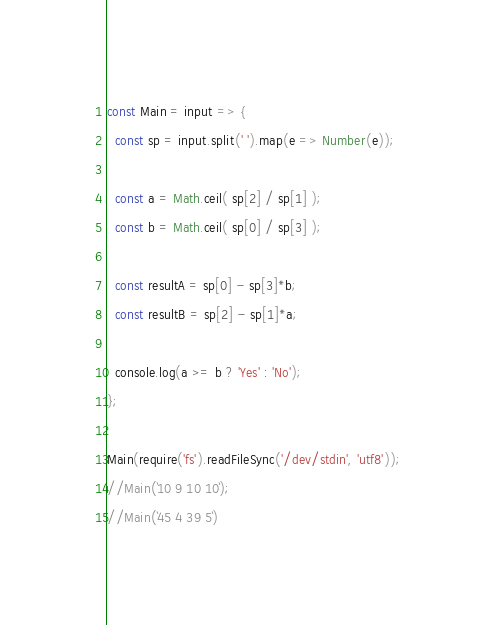<code> <loc_0><loc_0><loc_500><loc_500><_JavaScript_>const Main = input => {
  const sp = input.split(' ').map(e => Number(e));

  const a = Math.ceil( sp[2] / sp[1] );
  const b = Math.ceil( sp[0] / sp[3] );

  const resultA = sp[0] - sp[3]*b;
  const resultB = sp[2] - sp[1]*a;

  console.log(a >= b ? 'Yes' : 'No');
};

Main(require('fs').readFileSync('/dev/stdin', 'utf8'));
//Main(`10 9 10 10`);
//Main(`45 4 39 5`)
</code> 